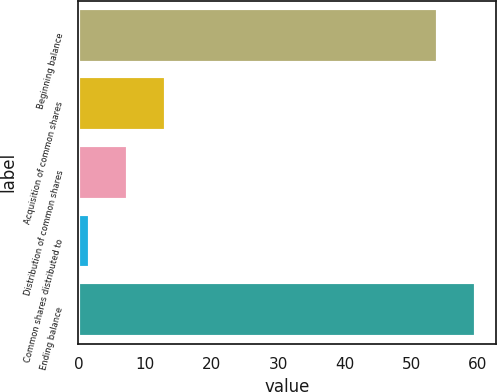Convert chart. <chart><loc_0><loc_0><loc_500><loc_500><bar_chart><fcel>Beginning balance<fcel>Acquisition of common shares<fcel>Distribution of common shares<fcel>Common shares distributed to<fcel>Ending balance<nl><fcel>54<fcel>13.2<fcel>7.45<fcel>1.7<fcel>59.75<nl></chart> 